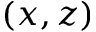Convert formula to latex. <formula><loc_0><loc_0><loc_500><loc_500>( x , z )</formula> 